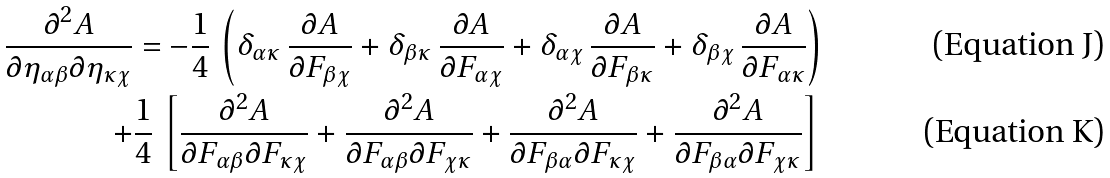<formula> <loc_0><loc_0><loc_500><loc_500>\frac { \partial ^ { 2 } A } { \partial \eta _ { \alpha \beta } \partial \eta _ { \kappa \chi } } & = - \frac { 1 } { 4 } \, \left ( \delta _ { \alpha \kappa } \, \frac { \partial A } { \partial F _ { \beta \chi } } + \delta _ { \beta \kappa } \, \frac { \partial A } { \partial F _ { \alpha \chi } } + \delta _ { \alpha \chi } \, \frac { \partial A } { \partial F _ { \beta \kappa } } + \delta _ { \beta \chi } \, \frac { \partial A } { \partial F _ { \alpha \kappa } } \right ) \\ + & \frac { 1 } { 4 } \, \left [ \frac { \partial ^ { 2 } A } { \partial F _ { \alpha \beta } \partial F _ { \kappa \chi } } + \frac { \partial ^ { 2 } A } { \partial F _ { \alpha \beta } \partial F _ { \chi \kappa } } + \frac { \partial ^ { 2 } A } { \partial F _ { \beta \alpha } \partial F _ { \kappa \chi } } + \frac { \partial ^ { 2 } A } { \partial F _ { \beta \alpha } \partial F _ { \chi \kappa } } \right ]</formula> 